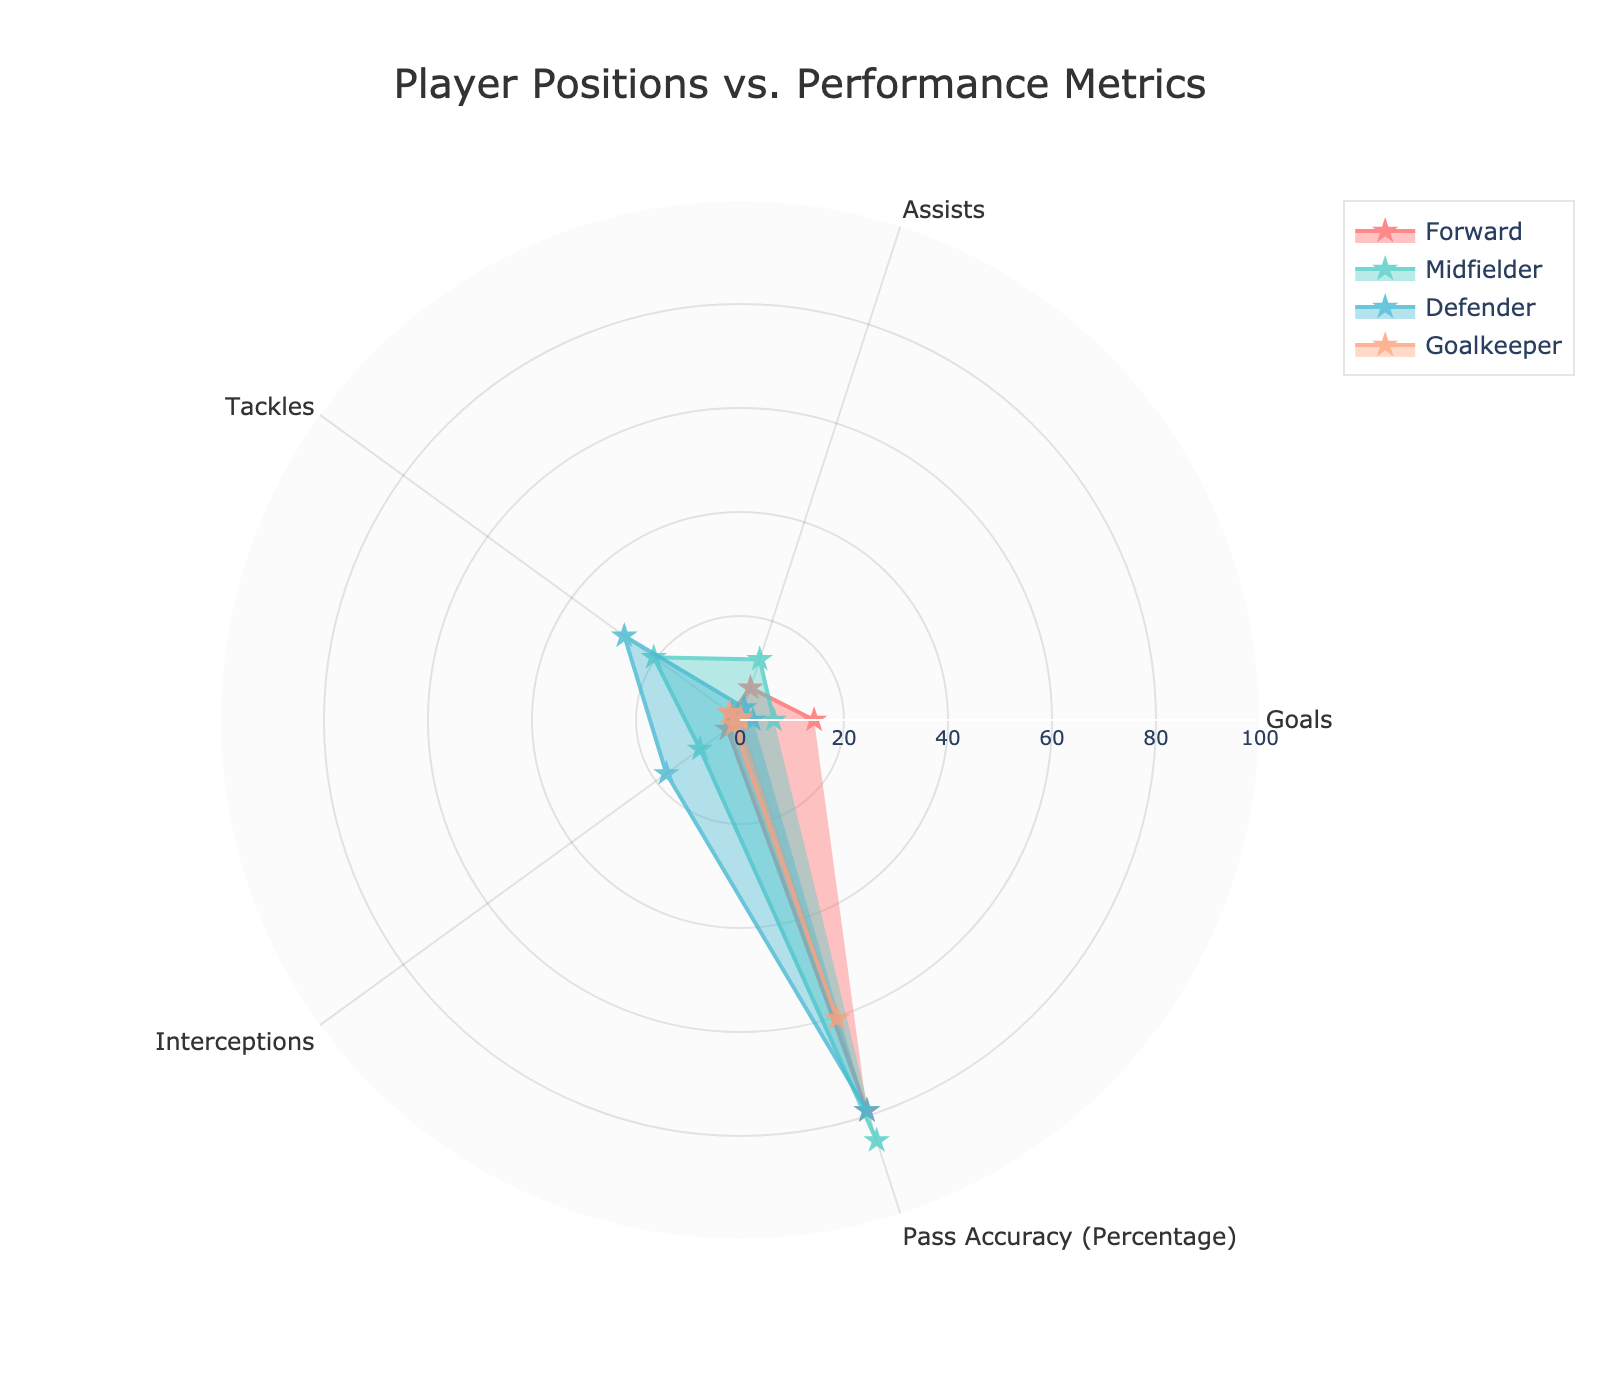How many performance metrics are displayed in the polar scatter chart? By looking at the chart, we can see that each player's performance is evaluated on several metrics, which are listed around the polar plot. Counting these, we find there are five metrics.
Answer: Five What is the average number of assists for midfielders? To calculate this, we take the assists of all midfielders (12 + 14 + 10 + 13) and divide by the number of midfielders (4). (12 + 14 + 10 + 13) / 4 = 12.25
Answer: 12.25 Which position has the highest average goals scored? Reviewing the chart, we can observe that forwards have the highest average on the goals metric. This is evident from the position of the forward curve in relation to the goals axis.
Answer: Forward What is the difference in average pass accuracy between defenders and goalkeepers? First, we calculate the average pass accuracy for defenders and goalkeepers separately. Then, we subtract the average pass accuracy of goalkeepers from that of defenders. Average pass accuracy for defenders is (79.6 + 77.8 + 80.1 + 78.3) / 4 = 78.95, and for goalkeepers is (59.4 + 60.7 + 62.5 + 58.9) / 4 = 60.375. The difference is 78.95 - 60.375 = 18.575
Answer: 18.575 Which position has the highest average tackles? From the chart, we can see that the defenders' data points extend farthest along the tackles axis compared to other positions' data points, indicating that defenders have the highest average number of tackles.
Answer: Defender Which metric has the least variance among all player positions? By observing the consistency of each metric for all player positions, pass accuracy appears to have the smallest variation, as the lines for all positions are closer together around this axis compared to other metrics.
Answer: Pass Accuracy How do the interception stats of goalkeepers compare to midfielders? Looking at the chart, the interception metric for goalkeepers is significantly lower as it is near the center, while for midfielders, it is positioned much higher on the axis.
Answer: Lower for Goalkeepers What's the average of the maximum values of tackles and interceptions across all positions? First, identify the maximum values for tackles and interceptions for each position from the figure, then take the average of these maximum values. For tackles, the maximum is for defenders (~30), and for interceptions, the maximum is for defenders (~20). The average is (30 + 20) / 2 = 25
Answer: 25 Which player position has the most balanced performance across all metrics? A balanced performance would appear as a more even and larger filled area. By comparing the shapes, the midfielder position fills out the chart more evenly across different metrics than other positions.
Answer: Midfielder 